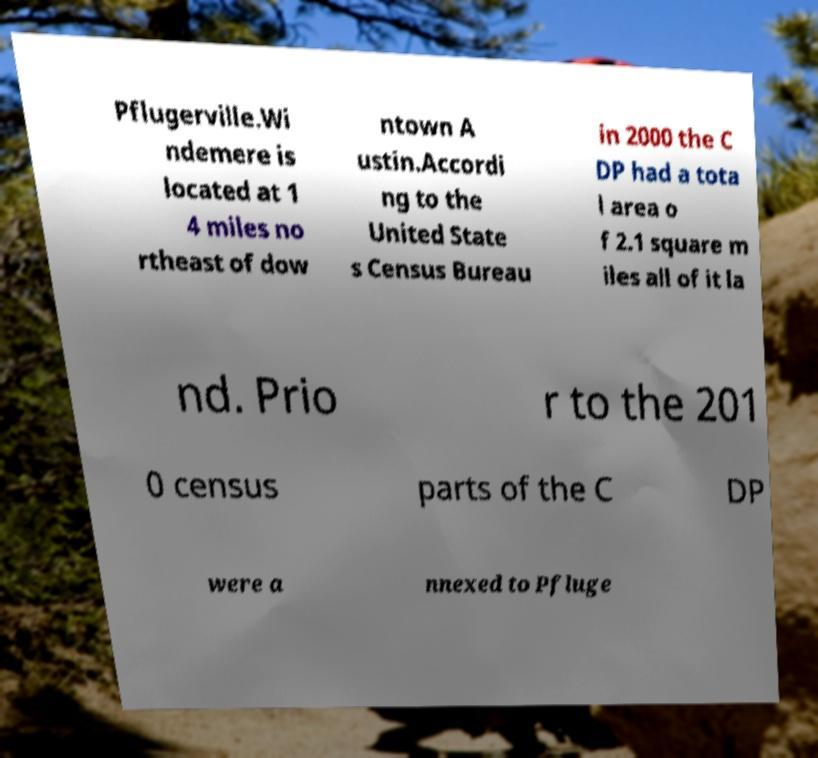Could you assist in decoding the text presented in this image and type it out clearly? Pflugerville.Wi ndemere is located at 1 4 miles no rtheast of dow ntown A ustin.Accordi ng to the United State s Census Bureau in 2000 the C DP had a tota l area o f 2.1 square m iles all of it la nd. Prio r to the 201 0 census parts of the C DP were a nnexed to Pfluge 